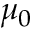Convert formula to latex. <formula><loc_0><loc_0><loc_500><loc_500>\mu _ { 0 }</formula> 